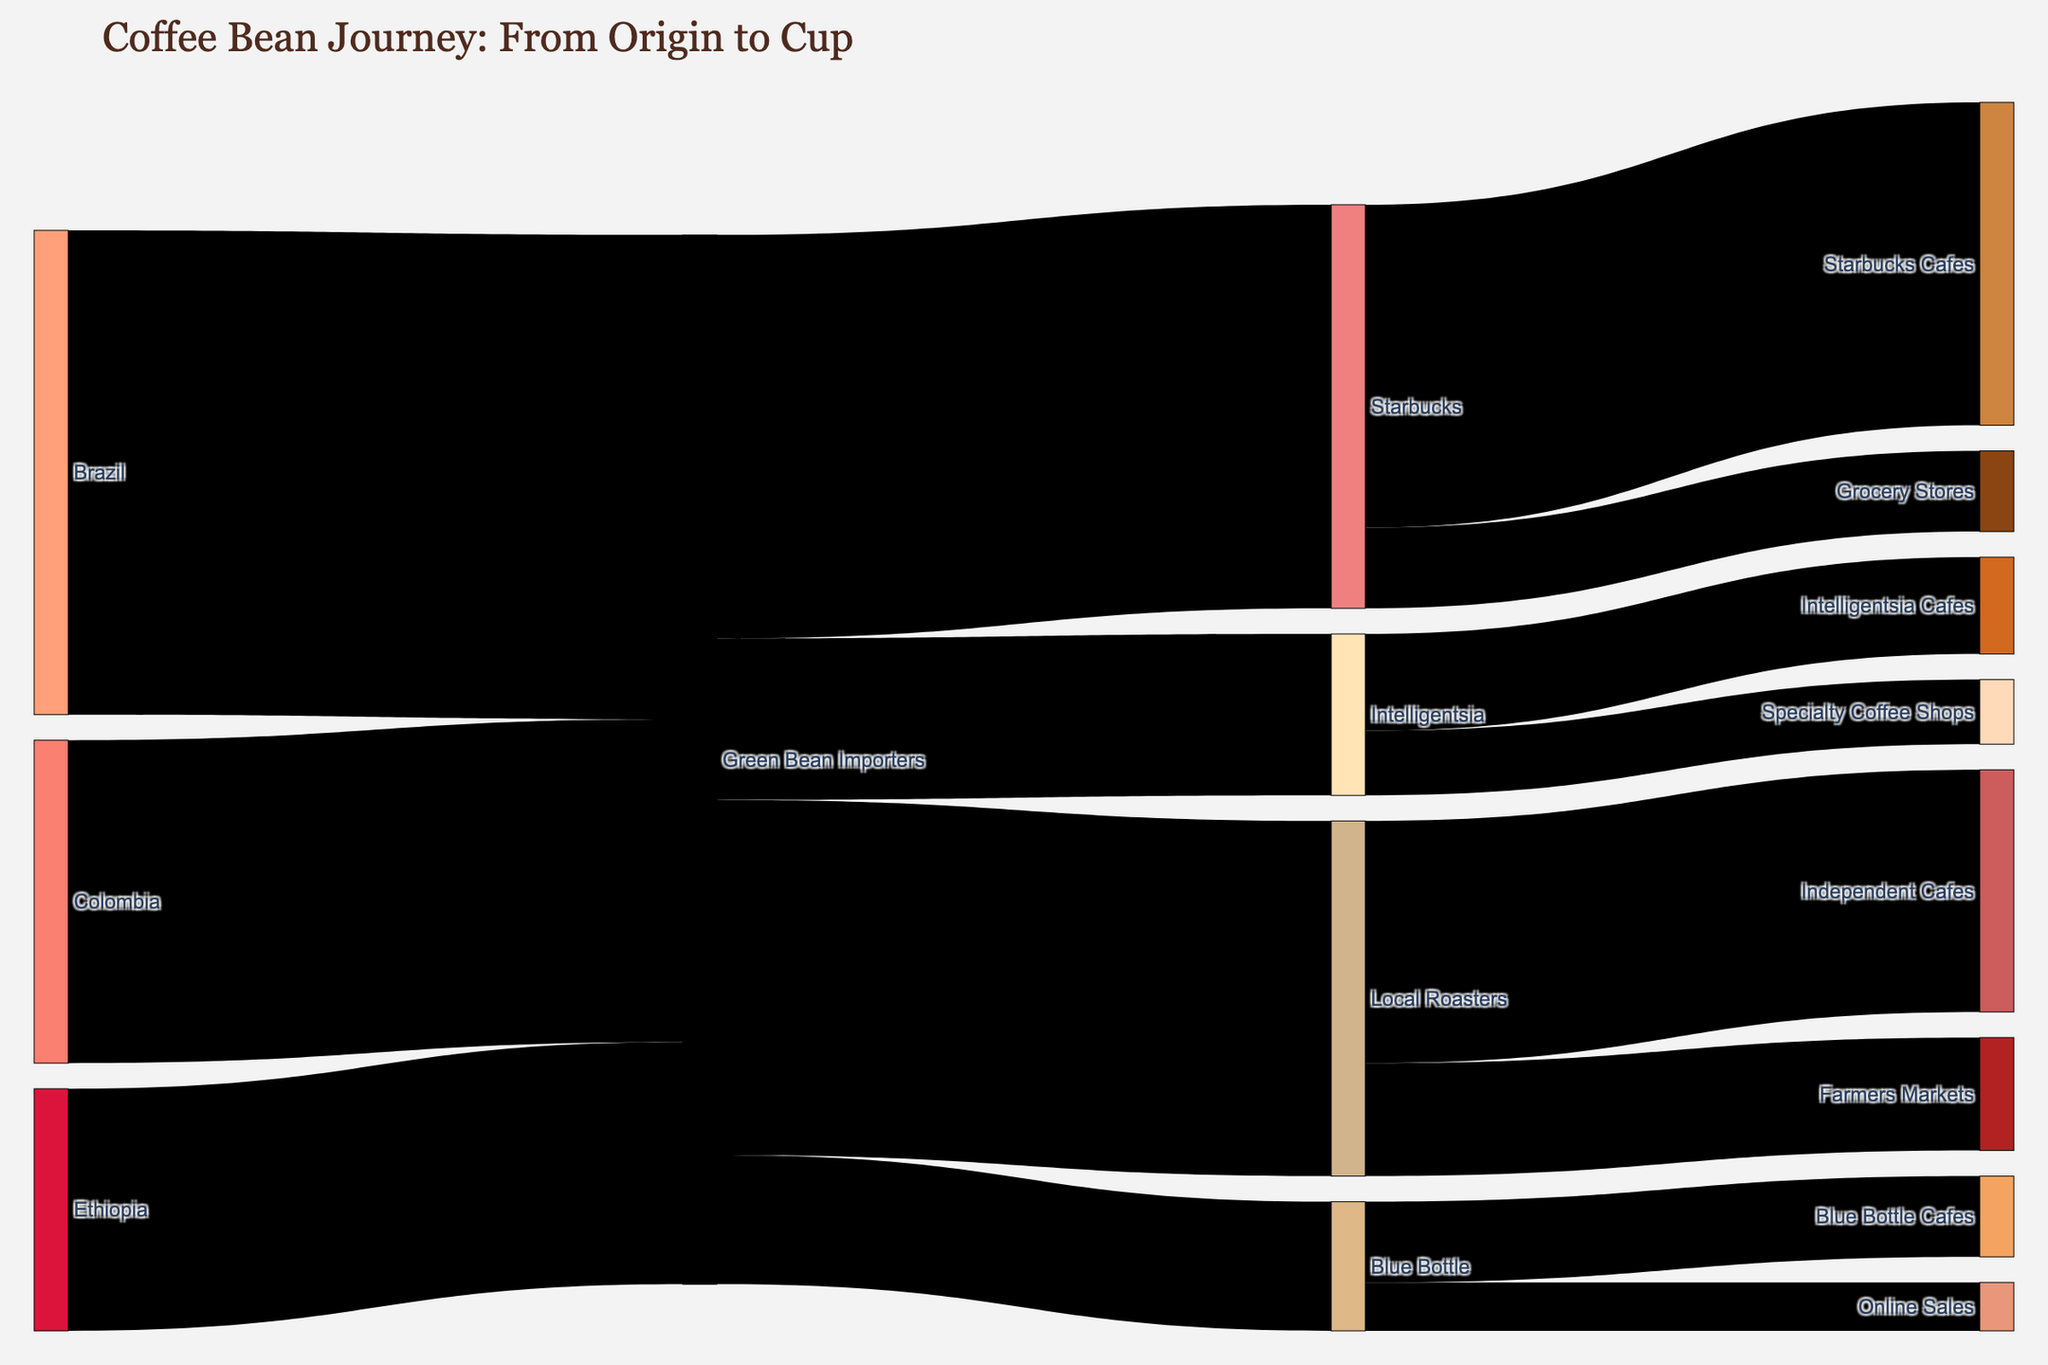Which country supplies the most coffee beans to Green Bean Importers? To determine the country supplying the most coffee beans to Green Bean Importers, look at the values connecting each country to Green Bean Importers. Brazil supplies 3000 units, which is higher than other countries.
Answer: Brazil How many coffee beans does Blue Bottle receive from Green Bean Importers? Look at the value connecting Green Bean Importers to Blue Bottle. The value is 800.
Answer: 800 Which distribution path involves the largest volume after Green Bean Importers? To find the largest volume involving a distribution path after Green Bean Importers, compare all subsequent connections. Green Bean Importers to Starbucks Cafes involves 2000 units, which is the largest.
Answer: Starbucks Cafes What is the total volume of coffee beans that Local Roasters handle? Sum the values connected to Local Roasters. From Green Bean Importers to Local Roasters is 2200, which then splits into 1500 (Independent Cafes) and 700 (Farmers Markets). So, 1500 + 700 = 2200.
Answer: 2200 How do the coffee bean volumes of Starbucks Cafes and Blue Bottle Cafes compare? Compare the values reaching Starbucks Cafes and Blue Bottle Cafes. Starbucks Cafes receive 2000 units, while Blue Bottle Cafes receive 500 units.
Answer: Starbucks Cafes receive more What is the total volume of coffee beans imported by Green Bean Importers? Sum the volumes imported by Green Bean Importers from all countries. 3000 (Brazil) + 2000 (Colombia) + 1500 (Ethiopia) = 6500.
Answer: 6500 Which entity receives the least amount of coffee beans from Green Bean Importers? Compare the values from Green Bean Importers to each entity. Blue Bottle receives 800 units, which is the least.
Answer: Blue Bottle How do the volumes of coffee beans imported from Ethiopia and Colombia compare? Compare the values directly connected from these countries to Green Bean Importers. Ethiopia supplies 1500 units, while Colombia supplies 2000 units.
Answer: Colombia supplies more What is the total volume of coffee beans that end up in cafes (all types)? Sum the volumes ending up in cafes. Starbucks Cafes (2000) + Intelligentsia Cafes (600) + Blue Bottle Cafes (500) + Independent Cafes (1500) = 4600.
Answer: 4600 From which country does Green Bean Importers receive the least amount of coffee beans? Compare the values of coffee beans imported from each country. Ethiopia supplies 1500 units, which is the least.
Answer: Ethiopia 